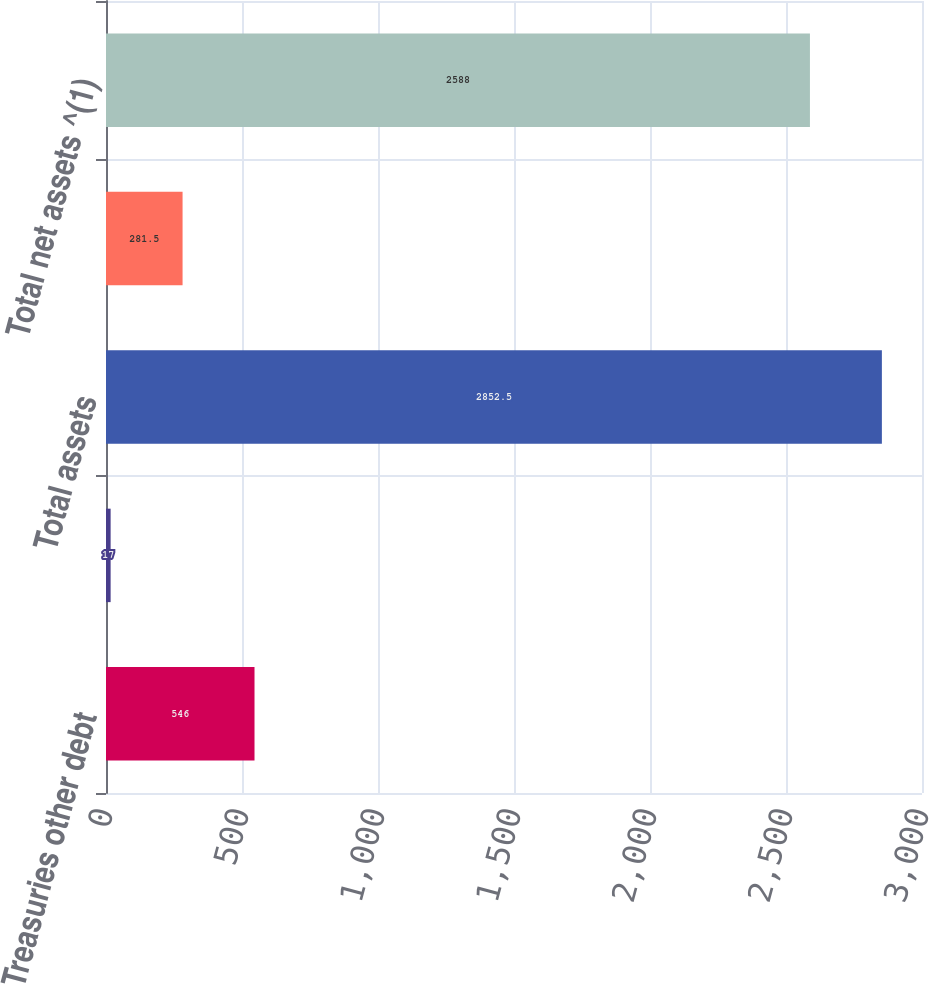Convert chart. <chart><loc_0><loc_0><loc_500><loc_500><bar_chart><fcel>Treasuries other debt<fcel>Other<fcel>Total assets<fcel>Total liabilities<fcel>Total net assets ^(1)<nl><fcel>546<fcel>17<fcel>2852.5<fcel>281.5<fcel>2588<nl></chart> 